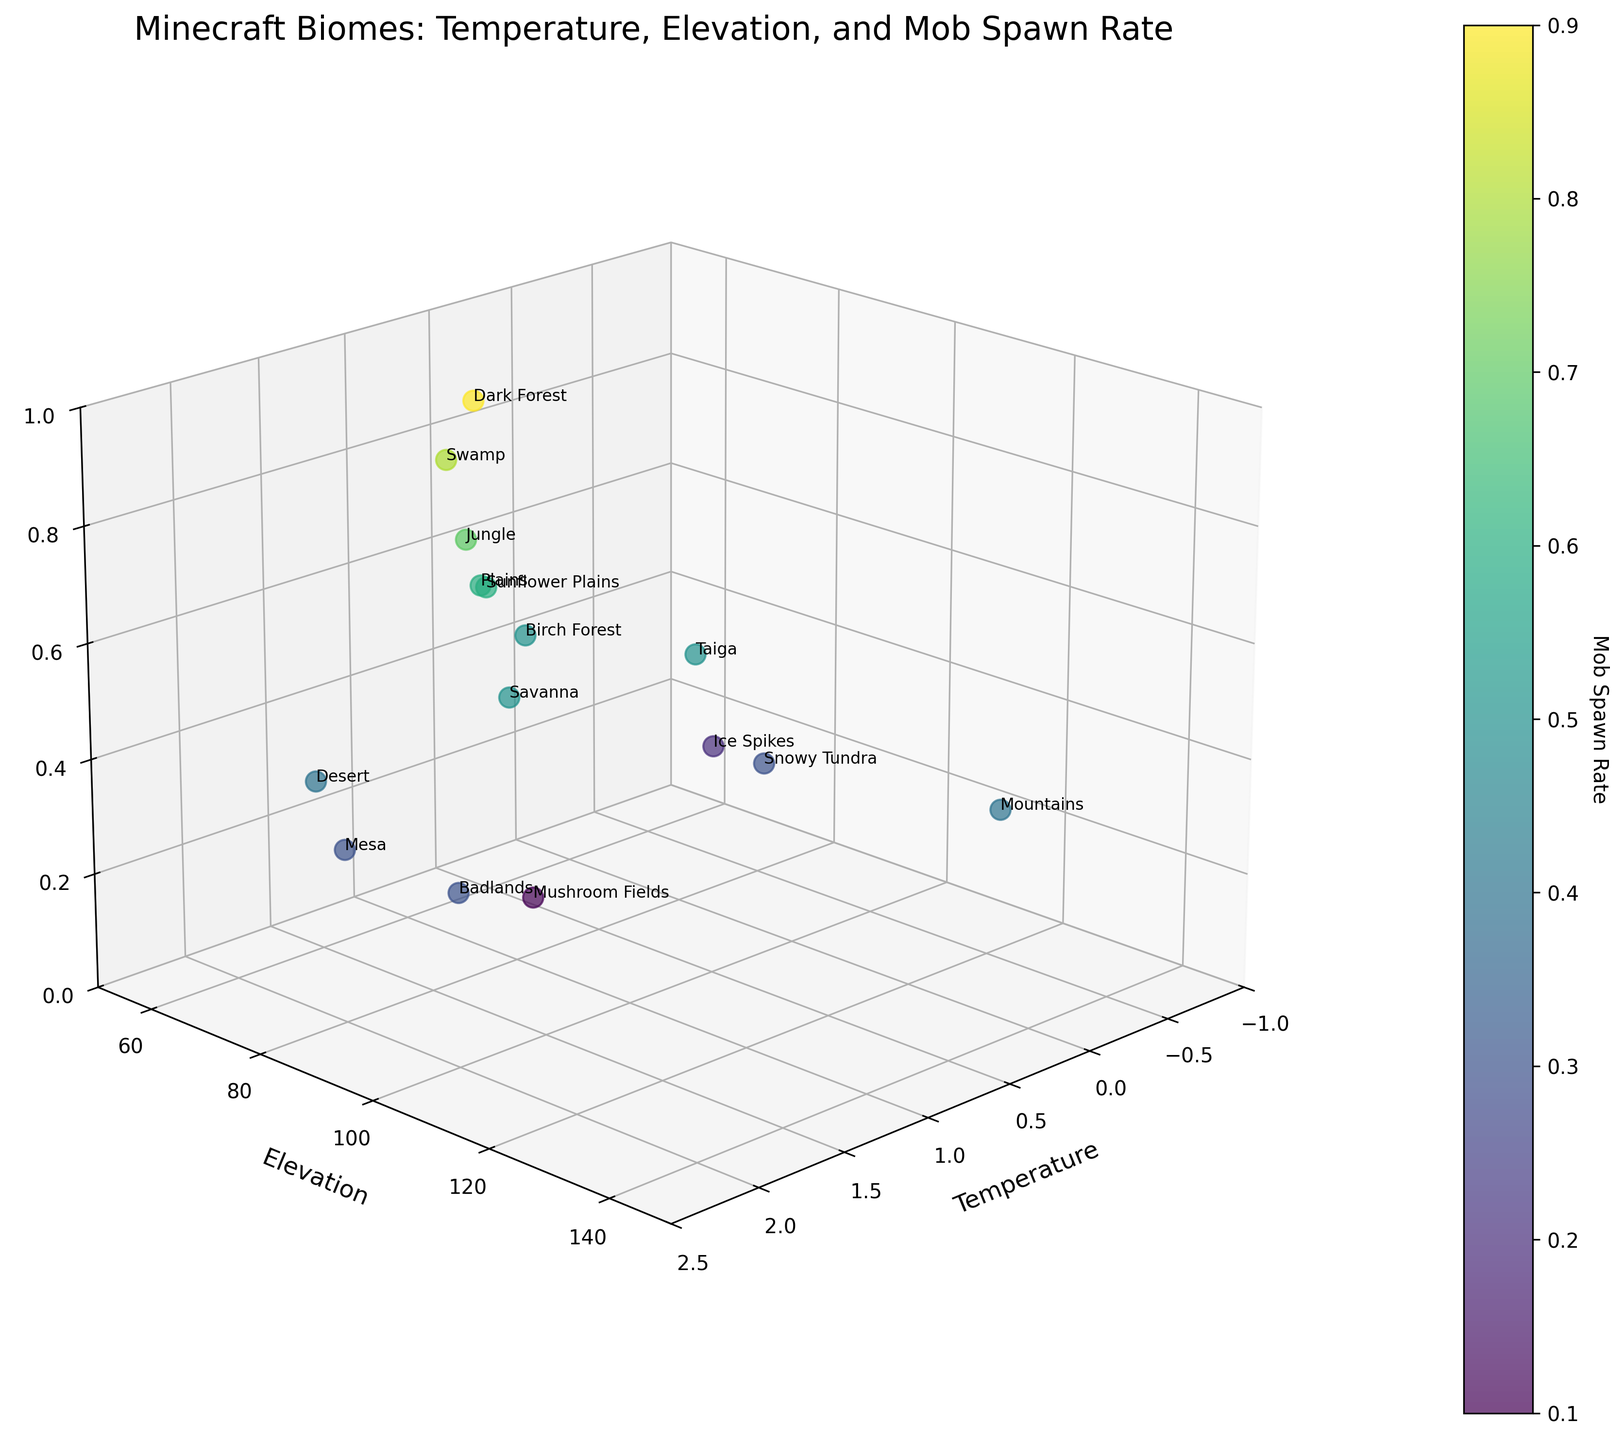How many biomes are labeled in the plot? Count the number of labeled points in the plot, which represent the different biomes shown.
Answer: 14 What is the title of the plot? Look at the top of the plot where the title is usually placed.
Answer: Minecraft Biomes: Temperature, Elevation, and Mob Spawn Rate Which biome has the highest elevation? Observe the y-axis representing elevation and find the biome label at the highest point.
Answer: Mountains What is the mob spawn rate for the Snowy Tundra biome? Locate the point labeled "Snowy Tundra" and refer to the color bar or z-axis for its mob spawn rate.
Answer: 0.3 How many biomes have a temperature greater than 1.5? Check all the points on the x-axis with a temperature value greater than 1.5.
Answer: 3 Which biomes have a mob spawn rate less than 0.5 and an elevation above 80? Find the points that meet both conditions by looking at the z-axis for a mob spawn rate <0.5 and the y-axis for elevation >80, then identify their labels.
Answer: Desert, Taiga, Snowy Tundra, Badlands, Mesa Which biome has the lowest temperature and what is its mob spawn rate? Look for the point with the lowest value on the x-axis representing temperature and refer to its mob spawn rate.
Answer: Ice Spikes, 0.2 Are there more biomes with temperatures below 1 or above 1? Count the points to the left (below 1) and right (above 1) of 1 on the x-axis and compare these counts.
Answer: More biomes with temperatures below 1 